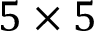<formula> <loc_0><loc_0><loc_500><loc_500>5 \times 5</formula> 